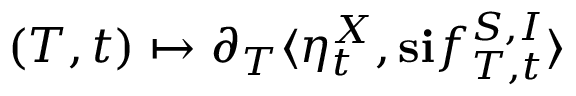Convert formula to latex. <formula><loc_0><loc_0><loc_500><loc_500>( T , t ) \mapsto \partial _ { T } \langle \eta _ { t } ^ { X } , s i f _ { T , t } ^ { S , I } \rangle</formula> 